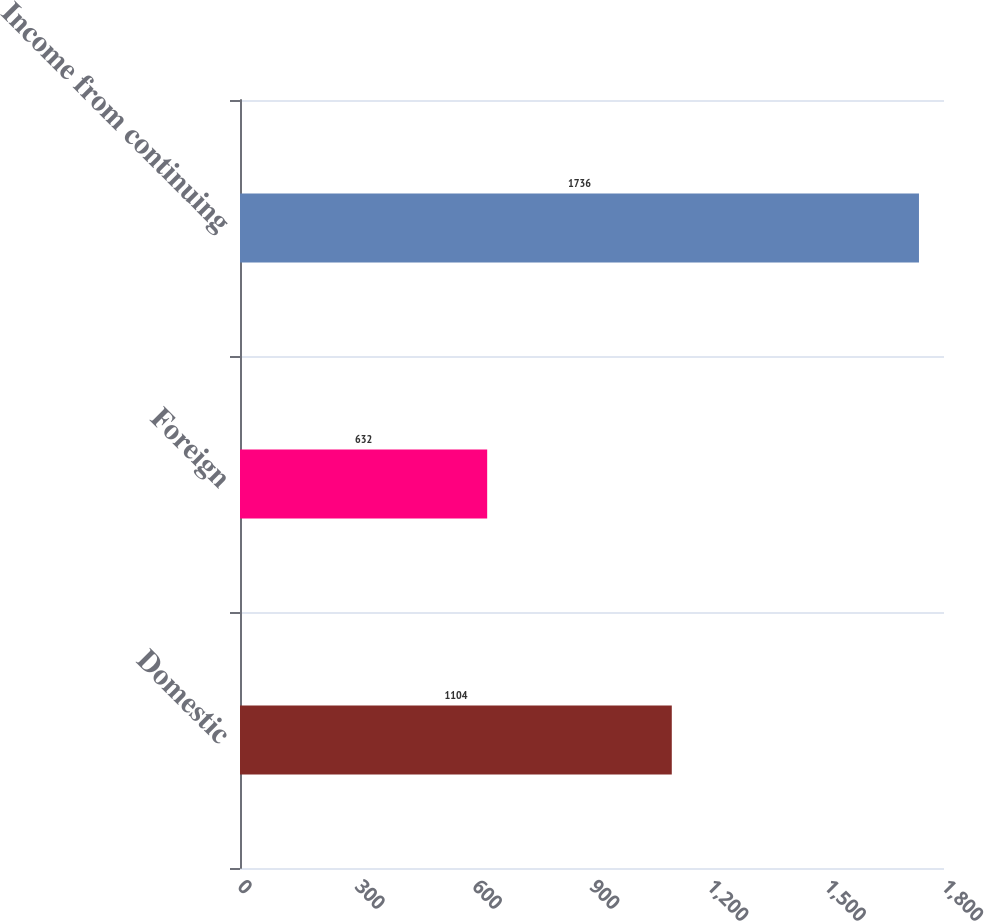Convert chart. <chart><loc_0><loc_0><loc_500><loc_500><bar_chart><fcel>Domestic<fcel>Foreign<fcel>Income from continuing<nl><fcel>1104<fcel>632<fcel>1736<nl></chart> 